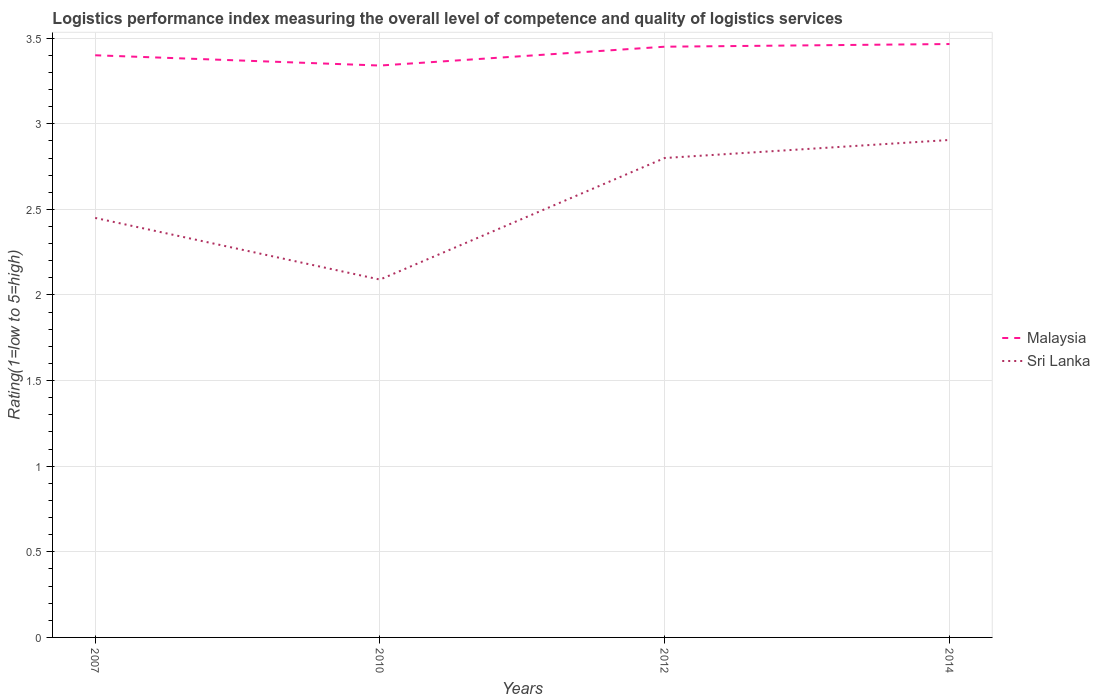How many different coloured lines are there?
Your response must be concise. 2. Is the number of lines equal to the number of legend labels?
Make the answer very short. Yes. Across all years, what is the maximum Logistic performance index in Malaysia?
Keep it short and to the point. 3.34. What is the total Logistic performance index in Sri Lanka in the graph?
Your response must be concise. -0.71. What is the difference between the highest and the second highest Logistic performance index in Malaysia?
Keep it short and to the point. 0.13. What is the difference between the highest and the lowest Logistic performance index in Sri Lanka?
Keep it short and to the point. 2. Are the values on the major ticks of Y-axis written in scientific E-notation?
Give a very brief answer. No. Does the graph contain grids?
Make the answer very short. Yes. Where does the legend appear in the graph?
Provide a succinct answer. Center right. What is the title of the graph?
Keep it short and to the point. Logistics performance index measuring the overall level of competence and quality of logistics services. Does "Hong Kong" appear as one of the legend labels in the graph?
Ensure brevity in your answer.  No. What is the label or title of the Y-axis?
Provide a short and direct response. Rating(1=low to 5=high). What is the Rating(1=low to 5=high) in Malaysia in 2007?
Ensure brevity in your answer.  3.4. What is the Rating(1=low to 5=high) of Sri Lanka in 2007?
Provide a succinct answer. 2.45. What is the Rating(1=low to 5=high) of Malaysia in 2010?
Offer a terse response. 3.34. What is the Rating(1=low to 5=high) in Sri Lanka in 2010?
Provide a short and direct response. 2.09. What is the Rating(1=low to 5=high) of Malaysia in 2012?
Make the answer very short. 3.45. What is the Rating(1=low to 5=high) in Malaysia in 2014?
Ensure brevity in your answer.  3.47. What is the Rating(1=low to 5=high) of Sri Lanka in 2014?
Provide a short and direct response. 2.91. Across all years, what is the maximum Rating(1=low to 5=high) in Malaysia?
Keep it short and to the point. 3.47. Across all years, what is the maximum Rating(1=low to 5=high) in Sri Lanka?
Keep it short and to the point. 2.91. Across all years, what is the minimum Rating(1=low to 5=high) of Malaysia?
Your answer should be compact. 3.34. Across all years, what is the minimum Rating(1=low to 5=high) in Sri Lanka?
Give a very brief answer. 2.09. What is the total Rating(1=low to 5=high) in Malaysia in the graph?
Provide a succinct answer. 13.66. What is the total Rating(1=low to 5=high) in Sri Lanka in the graph?
Ensure brevity in your answer.  10.25. What is the difference between the Rating(1=low to 5=high) in Malaysia in 2007 and that in 2010?
Keep it short and to the point. 0.06. What is the difference between the Rating(1=low to 5=high) of Sri Lanka in 2007 and that in 2010?
Your response must be concise. 0.36. What is the difference between the Rating(1=low to 5=high) of Malaysia in 2007 and that in 2012?
Keep it short and to the point. -0.05. What is the difference between the Rating(1=low to 5=high) in Sri Lanka in 2007 and that in 2012?
Provide a short and direct response. -0.35. What is the difference between the Rating(1=low to 5=high) of Malaysia in 2007 and that in 2014?
Provide a short and direct response. -0.07. What is the difference between the Rating(1=low to 5=high) in Sri Lanka in 2007 and that in 2014?
Keep it short and to the point. -0.46. What is the difference between the Rating(1=low to 5=high) in Malaysia in 2010 and that in 2012?
Offer a very short reply. -0.11. What is the difference between the Rating(1=low to 5=high) of Sri Lanka in 2010 and that in 2012?
Offer a very short reply. -0.71. What is the difference between the Rating(1=low to 5=high) of Malaysia in 2010 and that in 2014?
Ensure brevity in your answer.  -0.13. What is the difference between the Rating(1=low to 5=high) of Sri Lanka in 2010 and that in 2014?
Offer a terse response. -0.82. What is the difference between the Rating(1=low to 5=high) of Malaysia in 2012 and that in 2014?
Keep it short and to the point. -0.02. What is the difference between the Rating(1=low to 5=high) of Sri Lanka in 2012 and that in 2014?
Offer a very short reply. -0.11. What is the difference between the Rating(1=low to 5=high) in Malaysia in 2007 and the Rating(1=low to 5=high) in Sri Lanka in 2010?
Provide a short and direct response. 1.31. What is the difference between the Rating(1=low to 5=high) in Malaysia in 2007 and the Rating(1=low to 5=high) in Sri Lanka in 2014?
Your response must be concise. 0.49. What is the difference between the Rating(1=low to 5=high) of Malaysia in 2010 and the Rating(1=low to 5=high) of Sri Lanka in 2012?
Your answer should be very brief. 0.54. What is the difference between the Rating(1=low to 5=high) in Malaysia in 2010 and the Rating(1=low to 5=high) in Sri Lanka in 2014?
Ensure brevity in your answer.  0.43. What is the difference between the Rating(1=low to 5=high) in Malaysia in 2012 and the Rating(1=low to 5=high) in Sri Lanka in 2014?
Give a very brief answer. 0.54. What is the average Rating(1=low to 5=high) in Malaysia per year?
Your response must be concise. 3.41. What is the average Rating(1=low to 5=high) in Sri Lanka per year?
Ensure brevity in your answer.  2.56. In the year 2007, what is the difference between the Rating(1=low to 5=high) of Malaysia and Rating(1=low to 5=high) of Sri Lanka?
Make the answer very short. 0.95. In the year 2010, what is the difference between the Rating(1=low to 5=high) in Malaysia and Rating(1=low to 5=high) in Sri Lanka?
Your response must be concise. 1.25. In the year 2012, what is the difference between the Rating(1=low to 5=high) of Malaysia and Rating(1=low to 5=high) of Sri Lanka?
Make the answer very short. 0.65. In the year 2014, what is the difference between the Rating(1=low to 5=high) in Malaysia and Rating(1=low to 5=high) in Sri Lanka?
Your response must be concise. 0.56. What is the ratio of the Rating(1=low to 5=high) of Sri Lanka in 2007 to that in 2010?
Provide a short and direct response. 1.17. What is the ratio of the Rating(1=low to 5=high) in Malaysia in 2007 to that in 2012?
Ensure brevity in your answer.  0.99. What is the ratio of the Rating(1=low to 5=high) of Sri Lanka in 2007 to that in 2012?
Make the answer very short. 0.88. What is the ratio of the Rating(1=low to 5=high) in Malaysia in 2007 to that in 2014?
Provide a succinct answer. 0.98. What is the ratio of the Rating(1=low to 5=high) in Sri Lanka in 2007 to that in 2014?
Offer a terse response. 0.84. What is the ratio of the Rating(1=low to 5=high) in Malaysia in 2010 to that in 2012?
Keep it short and to the point. 0.97. What is the ratio of the Rating(1=low to 5=high) of Sri Lanka in 2010 to that in 2012?
Your answer should be compact. 0.75. What is the ratio of the Rating(1=low to 5=high) of Malaysia in 2010 to that in 2014?
Give a very brief answer. 0.96. What is the ratio of the Rating(1=low to 5=high) in Sri Lanka in 2010 to that in 2014?
Offer a terse response. 0.72. What is the ratio of the Rating(1=low to 5=high) in Sri Lanka in 2012 to that in 2014?
Make the answer very short. 0.96. What is the difference between the highest and the second highest Rating(1=low to 5=high) of Malaysia?
Your answer should be compact. 0.02. What is the difference between the highest and the second highest Rating(1=low to 5=high) in Sri Lanka?
Your response must be concise. 0.11. What is the difference between the highest and the lowest Rating(1=low to 5=high) in Malaysia?
Offer a very short reply. 0.13. What is the difference between the highest and the lowest Rating(1=low to 5=high) in Sri Lanka?
Offer a very short reply. 0.82. 